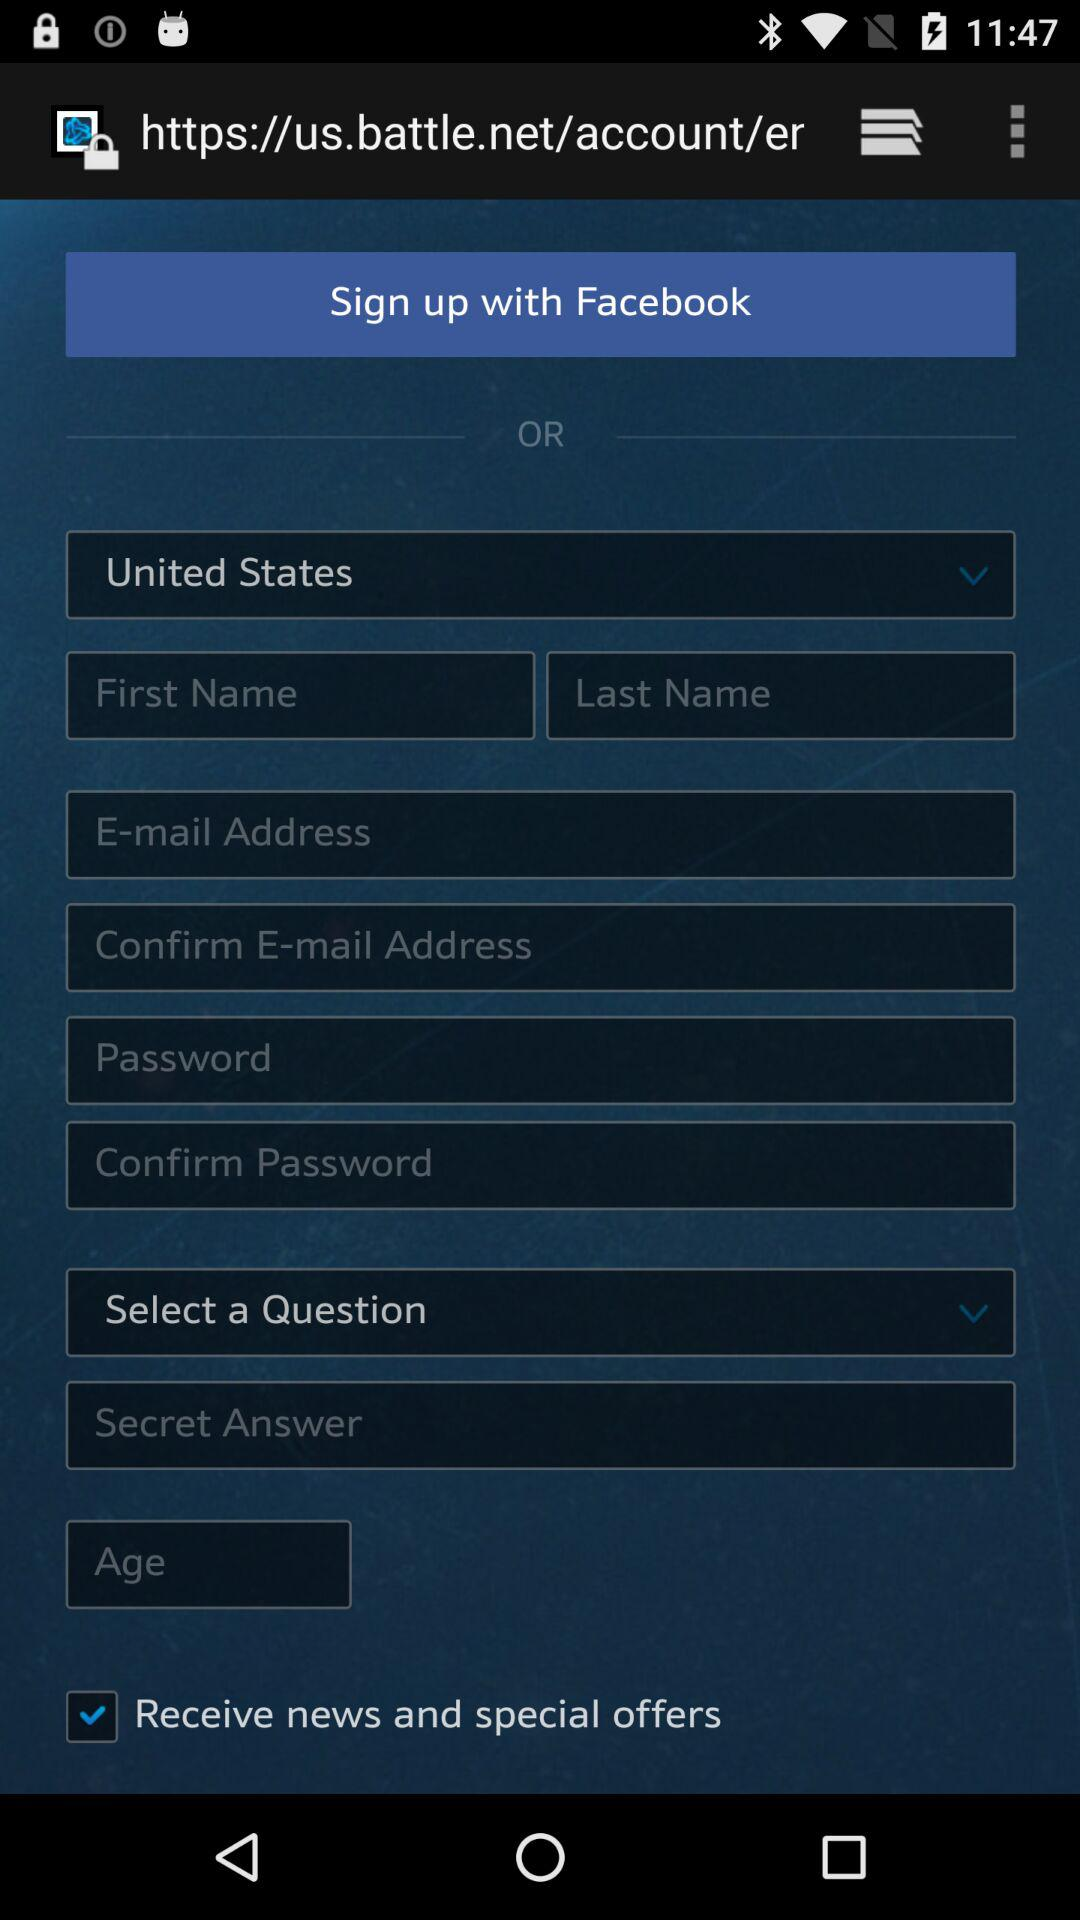Through which application can the user sign up? The user can sign up through "Facebook". 